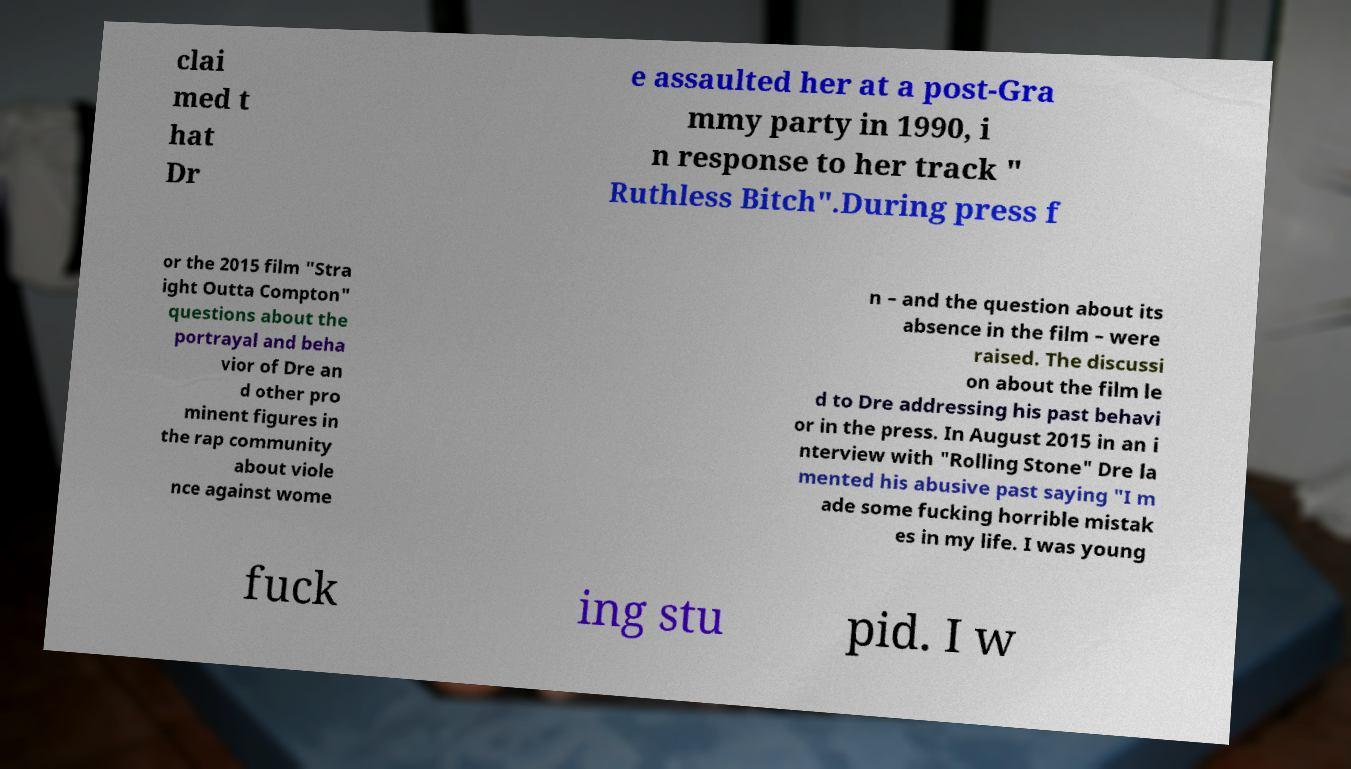Please identify and transcribe the text found in this image. clai med t hat Dr e assaulted her at a post-Gra mmy party in 1990, i n response to her track " Ruthless Bitch".During press f or the 2015 film "Stra ight Outta Compton" questions about the portrayal and beha vior of Dre an d other pro minent figures in the rap community about viole nce against wome n – and the question about its absence in the film – were raised. The discussi on about the film le d to Dre addressing his past behavi or in the press. In August 2015 in an i nterview with "Rolling Stone" Dre la mented his abusive past saying "I m ade some fucking horrible mistak es in my life. I was young fuck ing stu pid. I w 